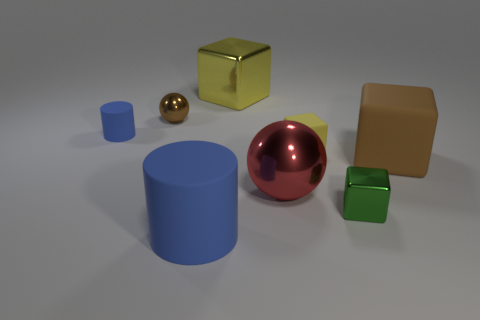What is the shape of the shiny thing that is behind the small blue rubber object and to the right of the tiny brown thing?
Offer a terse response. Cube. What is the shape of the blue rubber object in front of the brown object to the right of the big metallic block?
Offer a terse response. Cylinder. Does the large red object have the same shape as the large blue thing?
Ensure brevity in your answer.  No. There is a large cylinder that is the same color as the tiny cylinder; what is it made of?
Provide a short and direct response. Rubber. Is the tiny metallic block the same color as the small sphere?
Your answer should be compact. No. There is a yellow block that is left of the small matte object that is to the right of the red ball; what number of small brown shiny spheres are behind it?
Provide a succinct answer. 0. There is a big brown object that is the same material as the small yellow thing; what shape is it?
Provide a succinct answer. Cube. What is the material of the large block that is behind the brown object to the left of the blue object that is in front of the big red thing?
Ensure brevity in your answer.  Metal. What number of things are either blue objects that are behind the tiny green object or small yellow things?
Make the answer very short. 2. How many other objects are there of the same shape as the large yellow metallic object?
Provide a short and direct response. 3. 